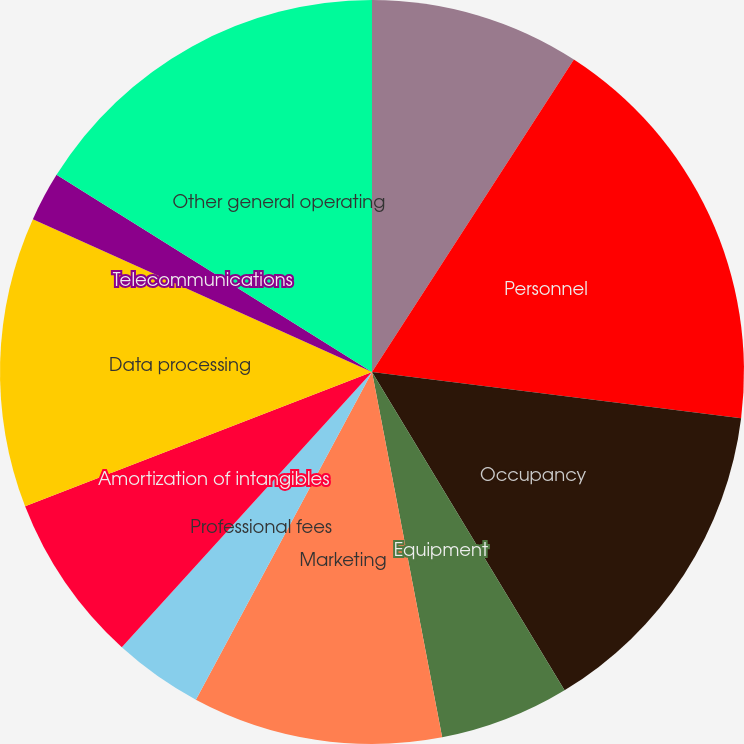Convert chart to OTSL. <chart><loc_0><loc_0><loc_500><loc_500><pie_chart><fcel>(Dollars in millions)<fcel>Personnel<fcel>Occupancy<fcel>Equipment<fcel>Marketing<fcel>Professional fees<fcel>Amortization of intangibles<fcel>Data processing<fcel>Telecommunications<fcel>Other general operating<nl><fcel>9.13%<fcel>17.85%<fcel>14.36%<fcel>5.64%<fcel>10.87%<fcel>3.89%<fcel>7.38%<fcel>12.62%<fcel>2.15%<fcel>16.11%<nl></chart> 